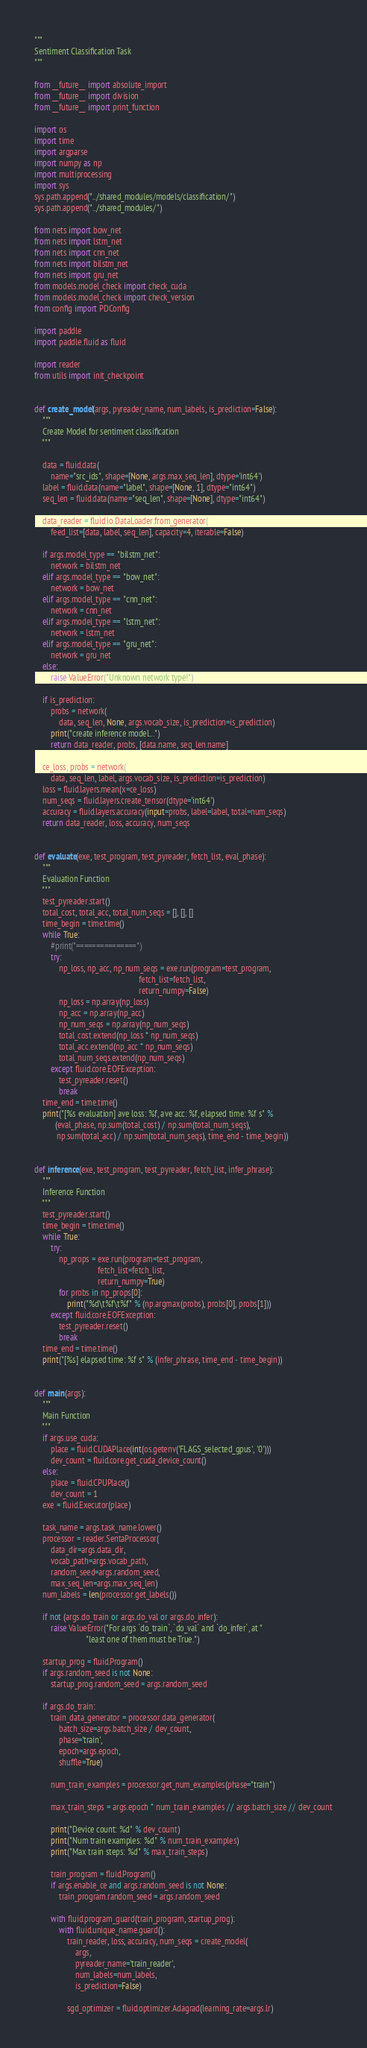<code> <loc_0><loc_0><loc_500><loc_500><_Python_>"""
Sentiment Classification Task
"""

from __future__ import absolute_import
from __future__ import division
from __future__ import print_function

import os
import time
import argparse
import numpy as np
import multiprocessing
import sys
sys.path.append("../shared_modules/models/classification/")
sys.path.append("../shared_modules/")

from nets import bow_net
from nets import lstm_net
from nets import cnn_net
from nets import bilstm_net
from nets import gru_net
from models.model_check import check_cuda
from models.model_check import check_version
from config import PDConfig

import paddle
import paddle.fluid as fluid

import reader
from utils import init_checkpoint


def create_model(args, pyreader_name, num_labels, is_prediction=False):
    """
    Create Model for sentiment classification
    """

    data = fluid.data(
        name="src_ids", shape=[None, args.max_seq_len], dtype='int64')
    label = fluid.data(name="label", shape=[None, 1], dtype="int64")
    seq_len = fluid.data(name="seq_len", shape=[None], dtype="int64")

    data_reader = fluid.io.DataLoader.from_generator(
        feed_list=[data, label, seq_len], capacity=4, iterable=False)

    if args.model_type == "bilstm_net":
        network = bilstm_net
    elif args.model_type == "bow_net":
        network = bow_net
    elif args.model_type == "cnn_net":
        network = cnn_net
    elif args.model_type == "lstm_net":
        network = lstm_net
    elif args.model_type == "gru_net":
        network = gru_net
    else:
        raise ValueError("Unknown network type!")

    if is_prediction:
        probs = network(
            data, seq_len, None, args.vocab_size, is_prediction=is_prediction)
        print("create inference model...")
        return data_reader, probs, [data.name, seq_len.name]

    ce_loss, probs = network(
        data, seq_len, label, args.vocab_size, is_prediction=is_prediction)
    loss = fluid.layers.mean(x=ce_loss)
    num_seqs = fluid.layers.create_tensor(dtype='int64')
    accuracy = fluid.layers.accuracy(input=probs, label=label, total=num_seqs)
    return data_reader, loss, accuracy, num_seqs


def evaluate(exe, test_program, test_pyreader, fetch_list, eval_phase):
    """
    Evaluation Function
    """
    test_pyreader.start()
    total_cost, total_acc, total_num_seqs = [], [], []
    time_begin = time.time()
    while True:
        #print("===============")
        try:
            np_loss, np_acc, np_num_seqs = exe.run(program=test_program,
                                                   fetch_list=fetch_list,
                                                   return_numpy=False)
            np_loss = np.array(np_loss)
            np_acc = np.array(np_acc)
            np_num_seqs = np.array(np_num_seqs)
            total_cost.extend(np_loss * np_num_seqs)
            total_acc.extend(np_acc * np_num_seqs)
            total_num_seqs.extend(np_num_seqs)
        except fluid.core.EOFException:
            test_pyreader.reset()
            break
    time_end = time.time()
    print("[%s evaluation] ave loss: %f, ave acc: %f, elapsed time: %f s" %
          (eval_phase, np.sum(total_cost) / np.sum(total_num_seqs),
           np.sum(total_acc) / np.sum(total_num_seqs), time_end - time_begin))


def inference(exe, test_program, test_pyreader, fetch_list, infer_phrase):
    """
    Inference Function
    """
    test_pyreader.start()
    time_begin = time.time()
    while True:
        try:
            np_props = exe.run(program=test_program,
                               fetch_list=fetch_list,
                               return_numpy=True)
            for probs in np_props[0]:
                print("%d\t%f\t%f" % (np.argmax(probs), probs[0], probs[1]))
        except fluid.core.EOFException:
            test_pyreader.reset()
            break
    time_end = time.time()
    print("[%s] elapsed time: %f s" % (infer_phrase, time_end - time_begin))


def main(args):
    """
    Main Function
    """
    if args.use_cuda:
        place = fluid.CUDAPlace(int(os.getenv('FLAGS_selected_gpus', '0')))
        dev_count = fluid.core.get_cuda_device_count()
    else:
        place = fluid.CPUPlace()
        dev_count = 1
    exe = fluid.Executor(place)

    task_name = args.task_name.lower()
    processor = reader.SentaProcessor(
        data_dir=args.data_dir,
        vocab_path=args.vocab_path,
        random_seed=args.random_seed,
        max_seq_len=args.max_seq_len)
    num_labels = len(processor.get_labels())

    if not (args.do_train or args.do_val or args.do_infer):
        raise ValueError("For args `do_train`, `do_val` and `do_infer`, at "
                         "least one of them must be True.")

    startup_prog = fluid.Program()
    if args.random_seed is not None:
        startup_prog.random_seed = args.random_seed

    if args.do_train:
        train_data_generator = processor.data_generator(
            batch_size=args.batch_size / dev_count,
            phase='train',
            epoch=args.epoch,
            shuffle=True)

        num_train_examples = processor.get_num_examples(phase="train")

        max_train_steps = args.epoch * num_train_examples // args.batch_size // dev_count

        print("Device count: %d" % dev_count)
        print("Num train examples: %d" % num_train_examples)
        print("Max train steps: %d" % max_train_steps)

        train_program = fluid.Program()
        if args.enable_ce and args.random_seed is not None:
            train_program.random_seed = args.random_seed

        with fluid.program_guard(train_program, startup_prog):
            with fluid.unique_name.guard():
                train_reader, loss, accuracy, num_seqs = create_model(
                    args,
                    pyreader_name='train_reader',
                    num_labels=num_labels,
                    is_prediction=False)

                sgd_optimizer = fluid.optimizer.Adagrad(learning_rate=args.lr)</code> 